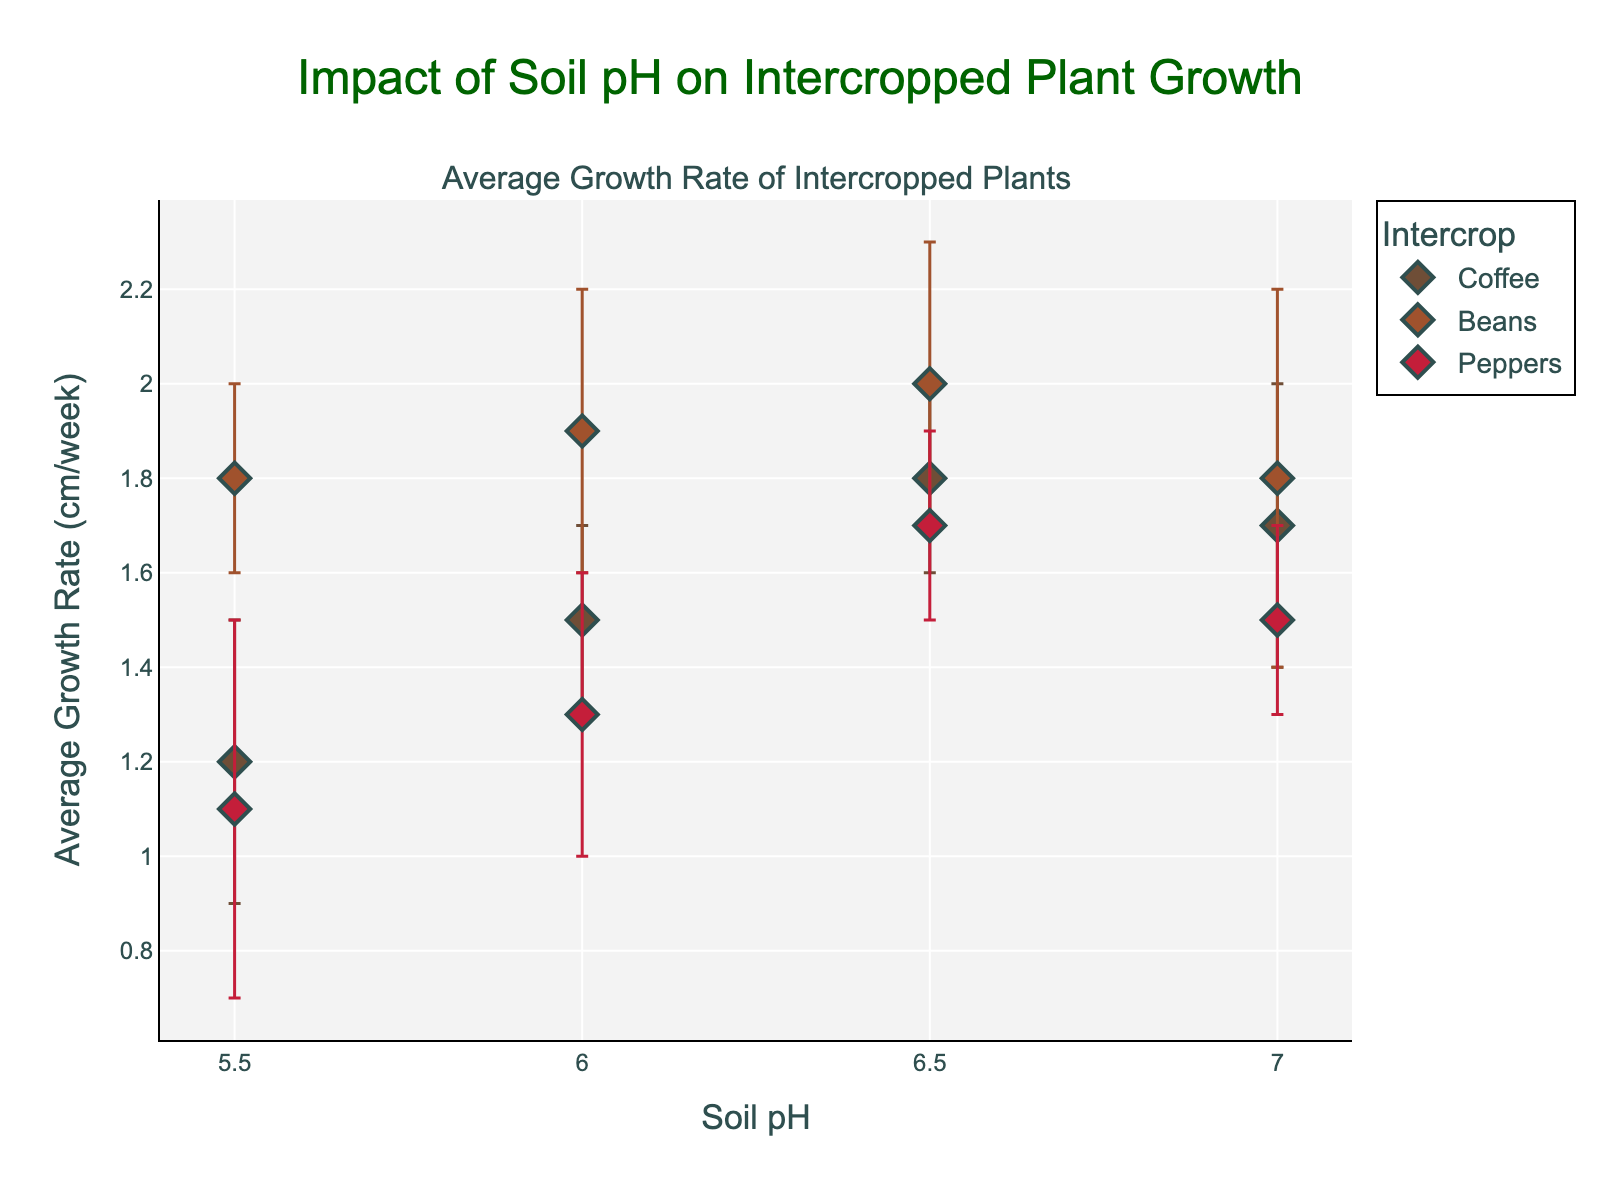What is the trend in the average growth rate of Coffee as the soil pH increases from 5.5 to 7.0? Examine the data points for Coffee as the soil pH value increases from 5.5 to 7.0. The average growth rate of Coffee increases up to 6.5 and then decreases slightly at 7.0.
Answer: Increases then decreases What is the difference in the average growth rates between Beans and Peppers at a soil pH of 7.0? Locate the data points for Beans and Peppers at a soil pH of 7.0 and subtract the average growth rate of Peppers from that of Beans. Beans: 1.8 cm/week, Peppers: 1.5 cm/week. The difference is 1.8 - 1.5 = 0.3 cm/week.
Answer: 0.3 cm/week Which intercrop at which soil pH level has the smallest standard deviation in growth rate? Look at the error bars to identify the smallest error bar among all data points. Coffee at a soil pH of 6.5 has the smallest standard deviation, indicated by the shortest error bar.
Answer: Coffee at 6.5 What is the average growth rate for Peppers at a soil pH of 5.5? Locate the data point for Peppers at a soil pH of 5.5. The y-value represents the average growth rate.
Answer: 1.1 cm/week How does the average growth rate of Beans change from a soil pH of 5.5 to 6.0? Look at the data points for Beans at soil pH values of 5.5 and 6.0. The average growth rate increases from 1.8 cm/week to 1.9 cm/week as the soil pH increases from 5.5 to 6.0.
Answer: Increases Which intercrop has the highest growth rate at the lowest soil pH level? At the lowest soil pH level of 5.5, compare the growth rates of Coffee, Beans, and Peppers. Beans have the highest growth rate at this soil pH level.
Answer: Beans How does the error bar length for Peppers change with increasing soil pH? Observe the error bars for Peppers across different soil pH levels. The error bar length stays roughly the same for Peppers as the soil pH changes, indicating consistent variability in growth rates.
Answer: Stays roughly the same 